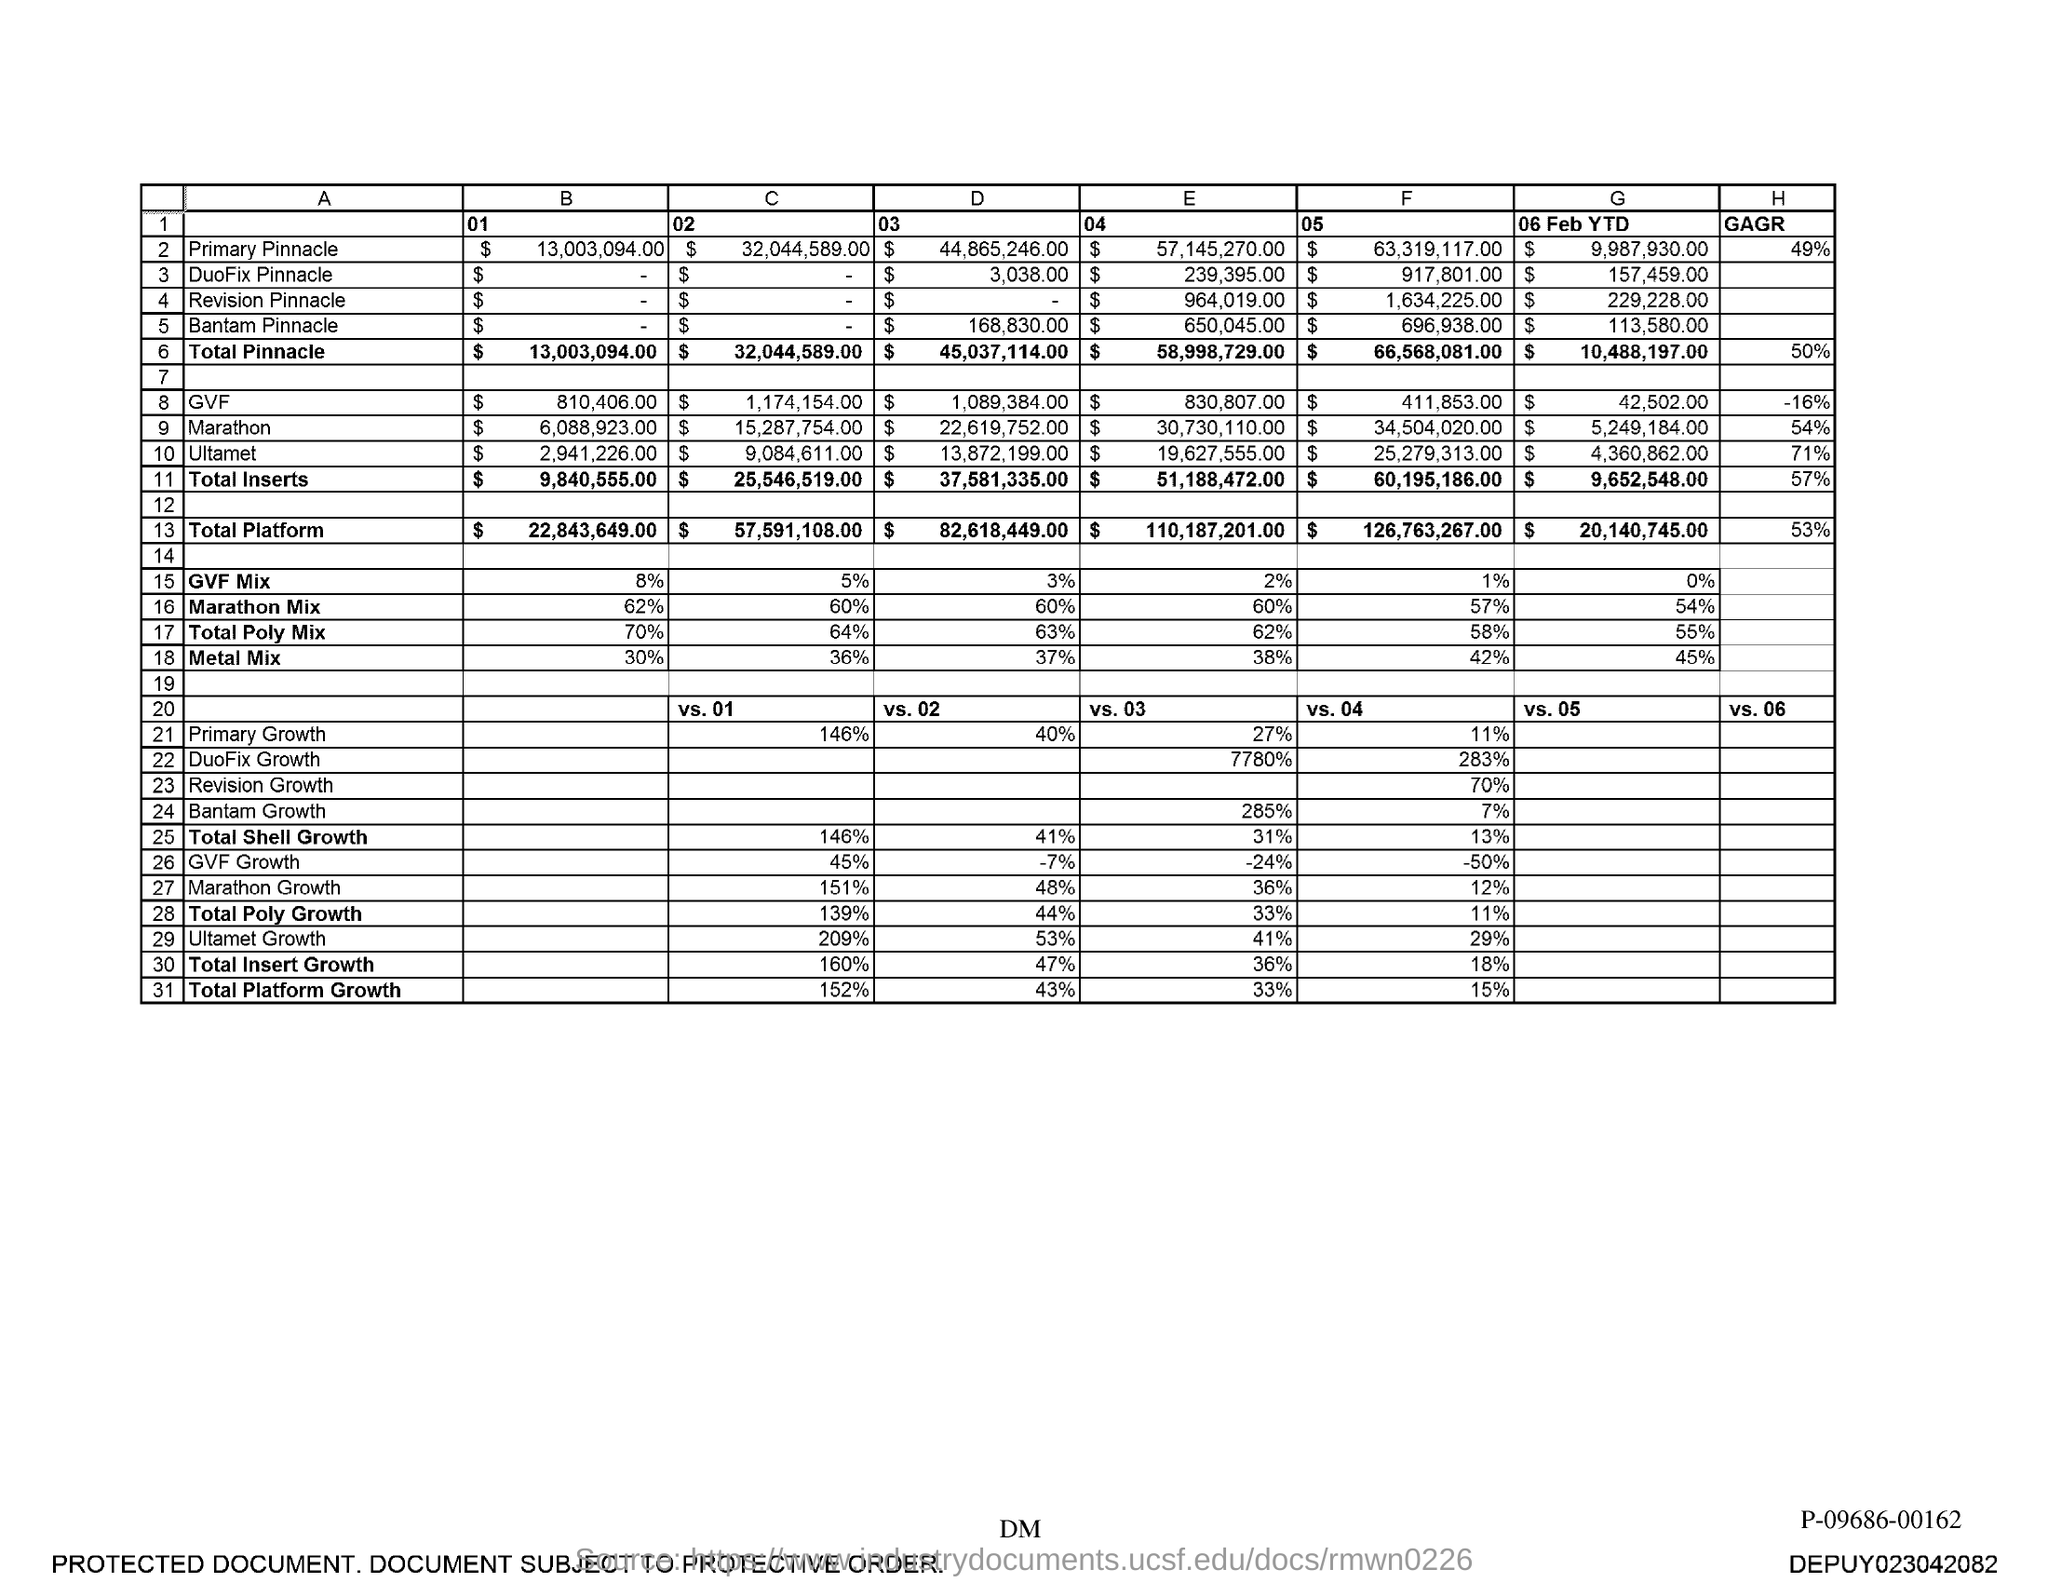Mention a couple of crucial points in this snapshot. The total Pinnacle value for column B is $13,003,094.00. 